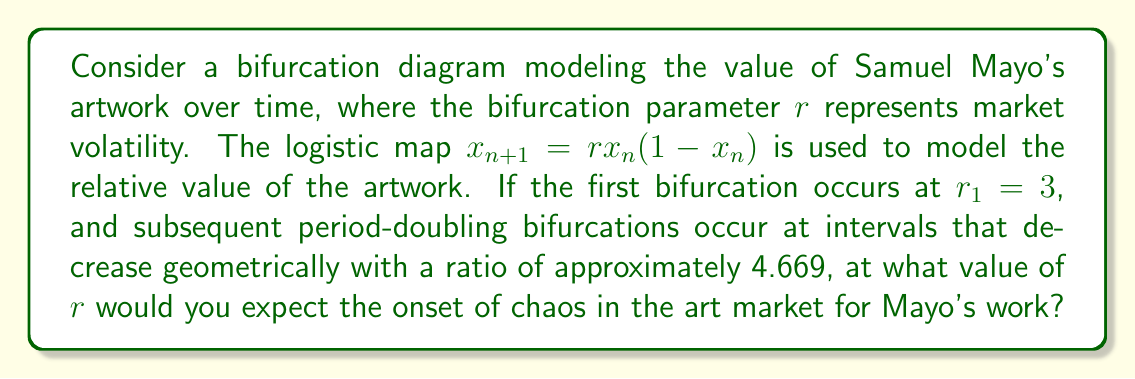Provide a solution to this math problem. To solve this problem, we'll use the Feigenbaum constant and the given information about the bifurcation points:

1) The Feigenbaum constant, $\delta \approx 4.669$, describes the ratio of successive bifurcation intervals.

2) Let's denote the onset of chaos as $r_\infty$. We need to find the limit of the sequence of bifurcation points.

3) The sequence of bifurcation points follows the pattern:
   $$r_1, r_2, r_3, ..., r_\infty$$

4) The intervals between bifurcations decrease geometrically:
   $$\frac{r_3 - r_2}{r_4 - r_3} \approx \frac{r_2 - r_1}{r_3 - r_2} \approx \delta \approx 4.669$$

5) We can express this as an infinite geometric series:
   $$r_\infty - r_1 = (r_2 - r_1) + (r_3 - r_2) + (r_4 - r_3) + ...$$

6) Let $a = r_2 - r_1$ be the first term of this series. Then:
   $$r_\infty - r_1 = a + \frac{a}{\delta} + \frac{a}{\delta^2} + ...$$

7) This is a geometric series with first term $a$ and ratio $\frac{1}{\delta}$. The sum of this infinite series is:
   $$r_\infty - r_1 = \frac{a}{1 - \frac{1}{\delta}} = \frac{a\delta}{\delta - 1}$$

8) We don't know $a$, but we know $r_1 = 3$. Solving for $r_\infty$:
   $$r_\infty = r_1 + \frac{a\delta}{\delta - 1} = 3 + \frac{a\delta}{\delta - 1}$$

9) Substituting $\delta \approx 4.669$:
   $$r_\infty \approx 3 + \frac{4.669a}{3.669} \approx 3 + 1.273a$$

10) The exact value of $a$ is not provided, but in the logistic map, $r_\infty$ is known to be approximately 3.57.

Therefore, the onset of chaos in the art market for Mayo's work would be expected at $r \approx 3.57$.
Answer: $r \approx 3.57$ 